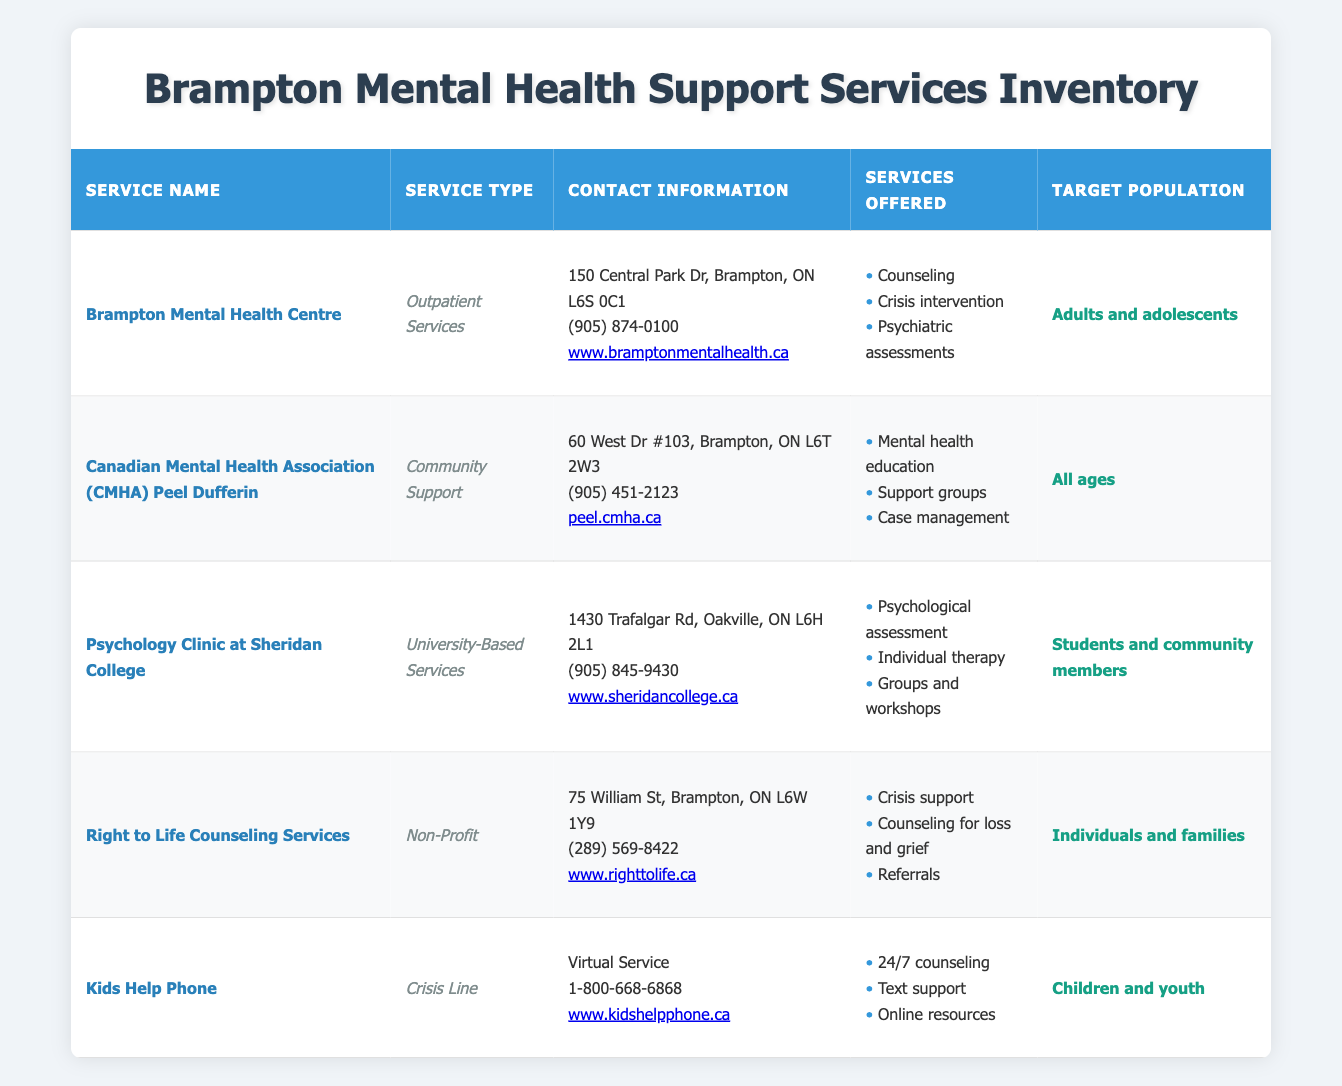What is the address of Brampton Mental Health Centre? The table lists the contact information for each service. For Brampton Mental Health Centre, the address is indicated in the third column as "150 Central Park Dr, Brampton, ON L6S 0C1".
Answer: 150 Central Park Dr, Brampton, ON L6S 0C1 How many services are offered by the Kids Help Phone? Looking in the fourth column under "Services Offered" for Kids Help Phone, it lists three services: "24/7 counseling", "Text support", and "Online resources". Therefore, the count is three.
Answer: 3 Is the Canadian Mental Health Association (CMHA) Peel Dufferin targeted at all ages? The table shows under "Target Population" for CMHA Peel Dufferin that it specifically mentions "All ages", confirming that this is true.
Answer: Yes Which service offers crisis support and counseling for loss and grief? Reviewing the "Services Offered" column, Right to Life Counseling Services is the one that lists both "Crisis support" and "Counseling for loss and grief", indicating that it offers these services.
Answer: Right to Life Counseling Services What type of service is Kids Help Phone categorized under? In the second column, labeled "Service Type", Kids Help Phone is classified as a "Crisis Line", which indicates the specific type of service it provides.
Answer: Crisis Line How many mental health support services are targeted specifically at adults and adolescents? To answer this, we look at the "Target Population" for each service. Only Brampton Mental Health Centre is targeted at "Adults and adolescents". Thus, there is a total of one service fitting this criterion.
Answer: 1 What services are offered by the Psychology Clinic at Sheridan College? Looking at the "Services Offered" column, the Psychology Clinic at Sheridan College provides three distinct services: "Psychological assessment", "Individual therapy", and "Groups and workshops".
Answer: Psychological assessment, Individual therapy, Groups and workshops Does Brampton Mental Health Centre provide psychiatric assessments? According to the "Services Offered" column for Brampton Mental Health Centre, it includes "Psychiatric assessments" among its services, confirming that this is true.
Answer: Yes Which service caters to children and youth and runs as a virtual service? By examining the "Target Population" column, the Kids Help Phone is specified to cater to "Children and youth", while in the address section it mentions "Virtual Service", confirming it meets this criterion.
Answer: Kids Help Phone 